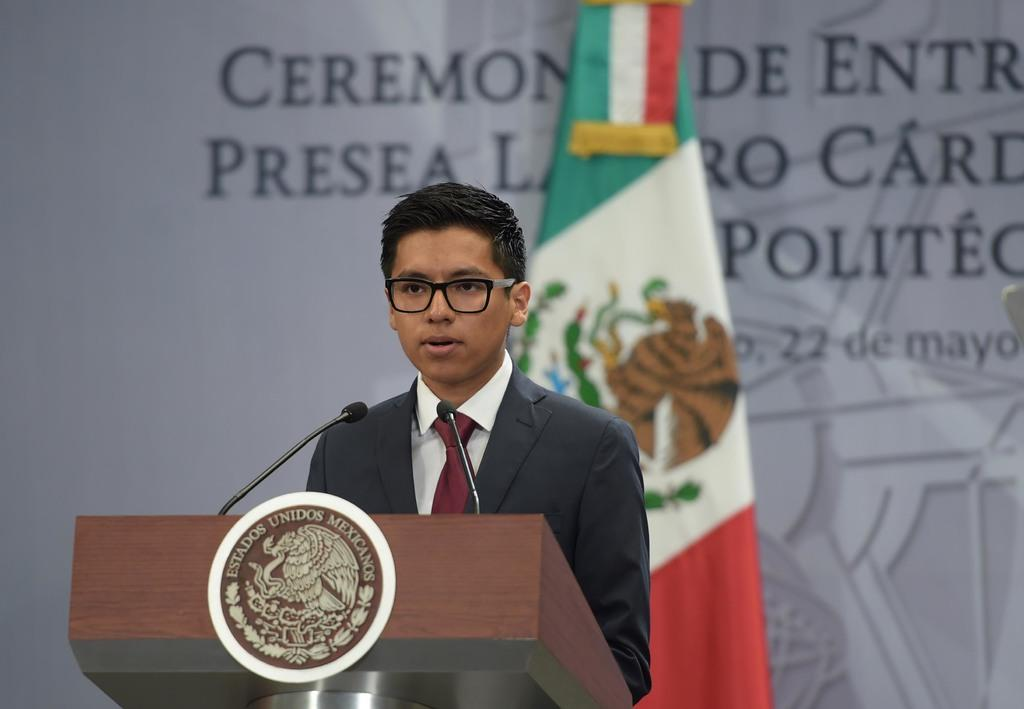Who is the main subject in the image? There is a boy in the image. What is the boy doing in the image? The boy is standing behind a podium. What can be seen on the podium? There are microphones on the podium. What is visible in the background of the image? There is a flag and a banner in the background of the image. What type of mask is the boy wearing in the image? There is no mask visible on the boy in the image. What news event is the boy reporting on in the image? The image does not provide any information about a news event or the boy's role in reporting news. 